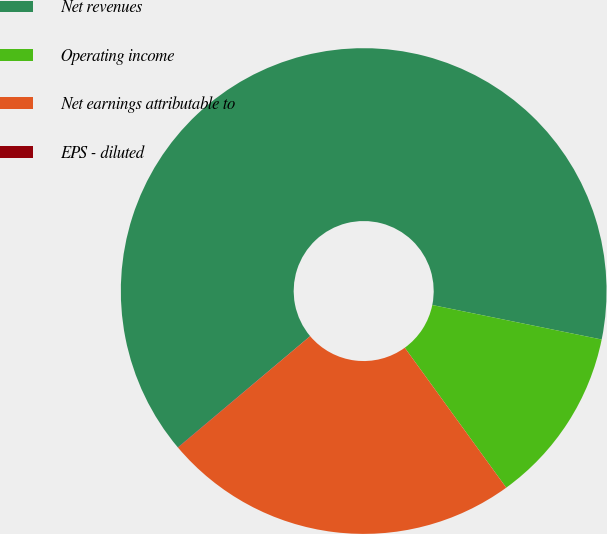<chart> <loc_0><loc_0><loc_500><loc_500><pie_chart><fcel>Net revenues<fcel>Operating income<fcel>Net earnings attributable to<fcel>EPS - diluted<nl><fcel>64.33%<fcel>11.82%<fcel>23.83%<fcel>0.02%<nl></chart> 